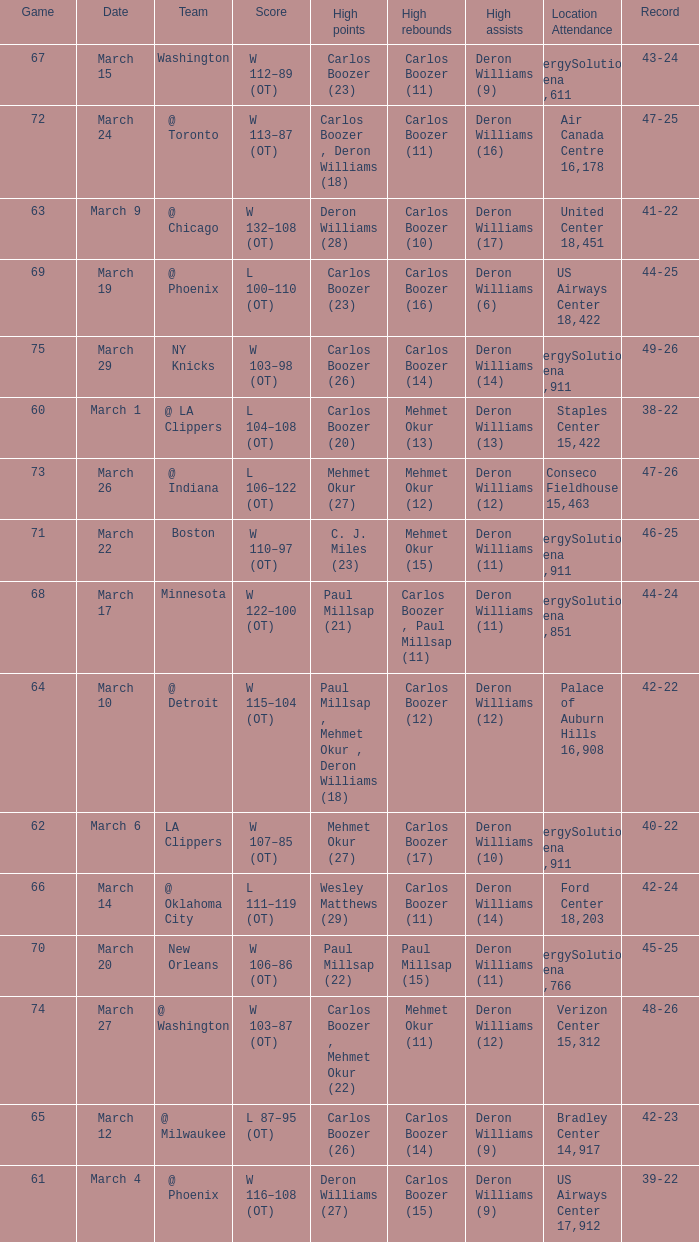How many players did the most high points in the game with 39-22 record? 1.0. 